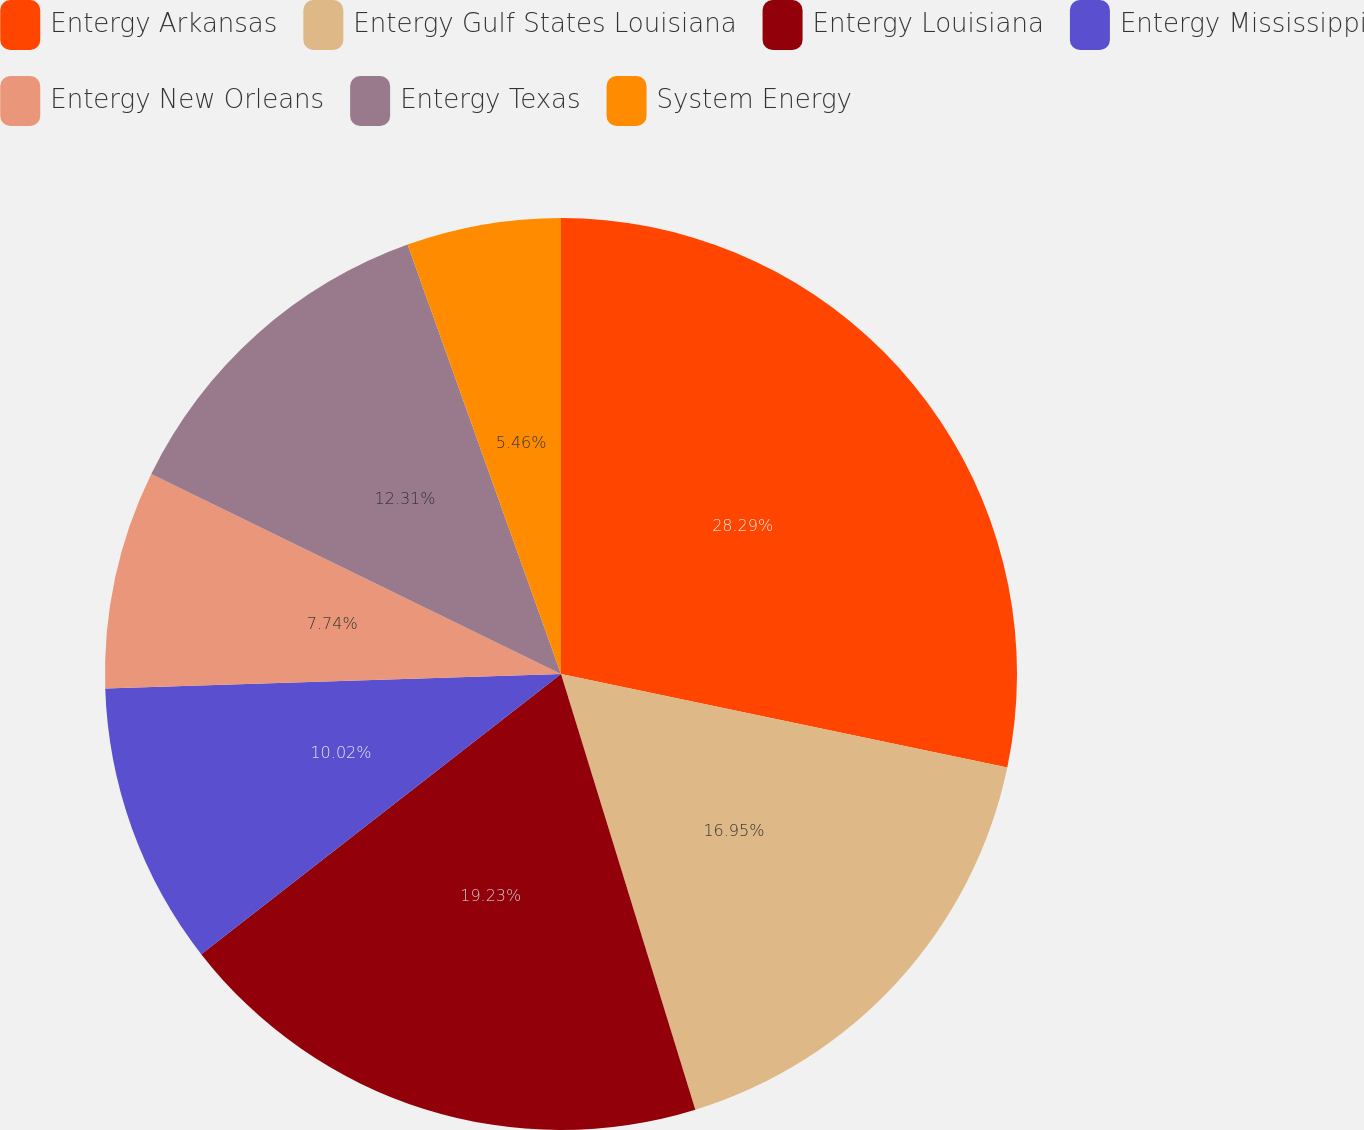<chart> <loc_0><loc_0><loc_500><loc_500><pie_chart><fcel>Entergy Arkansas<fcel>Entergy Gulf States Louisiana<fcel>Entergy Louisiana<fcel>Entergy Mississippi<fcel>Entergy New Orleans<fcel>Entergy Texas<fcel>System Energy<nl><fcel>28.29%<fcel>16.95%<fcel>19.23%<fcel>10.02%<fcel>7.74%<fcel>12.31%<fcel>5.46%<nl></chart> 